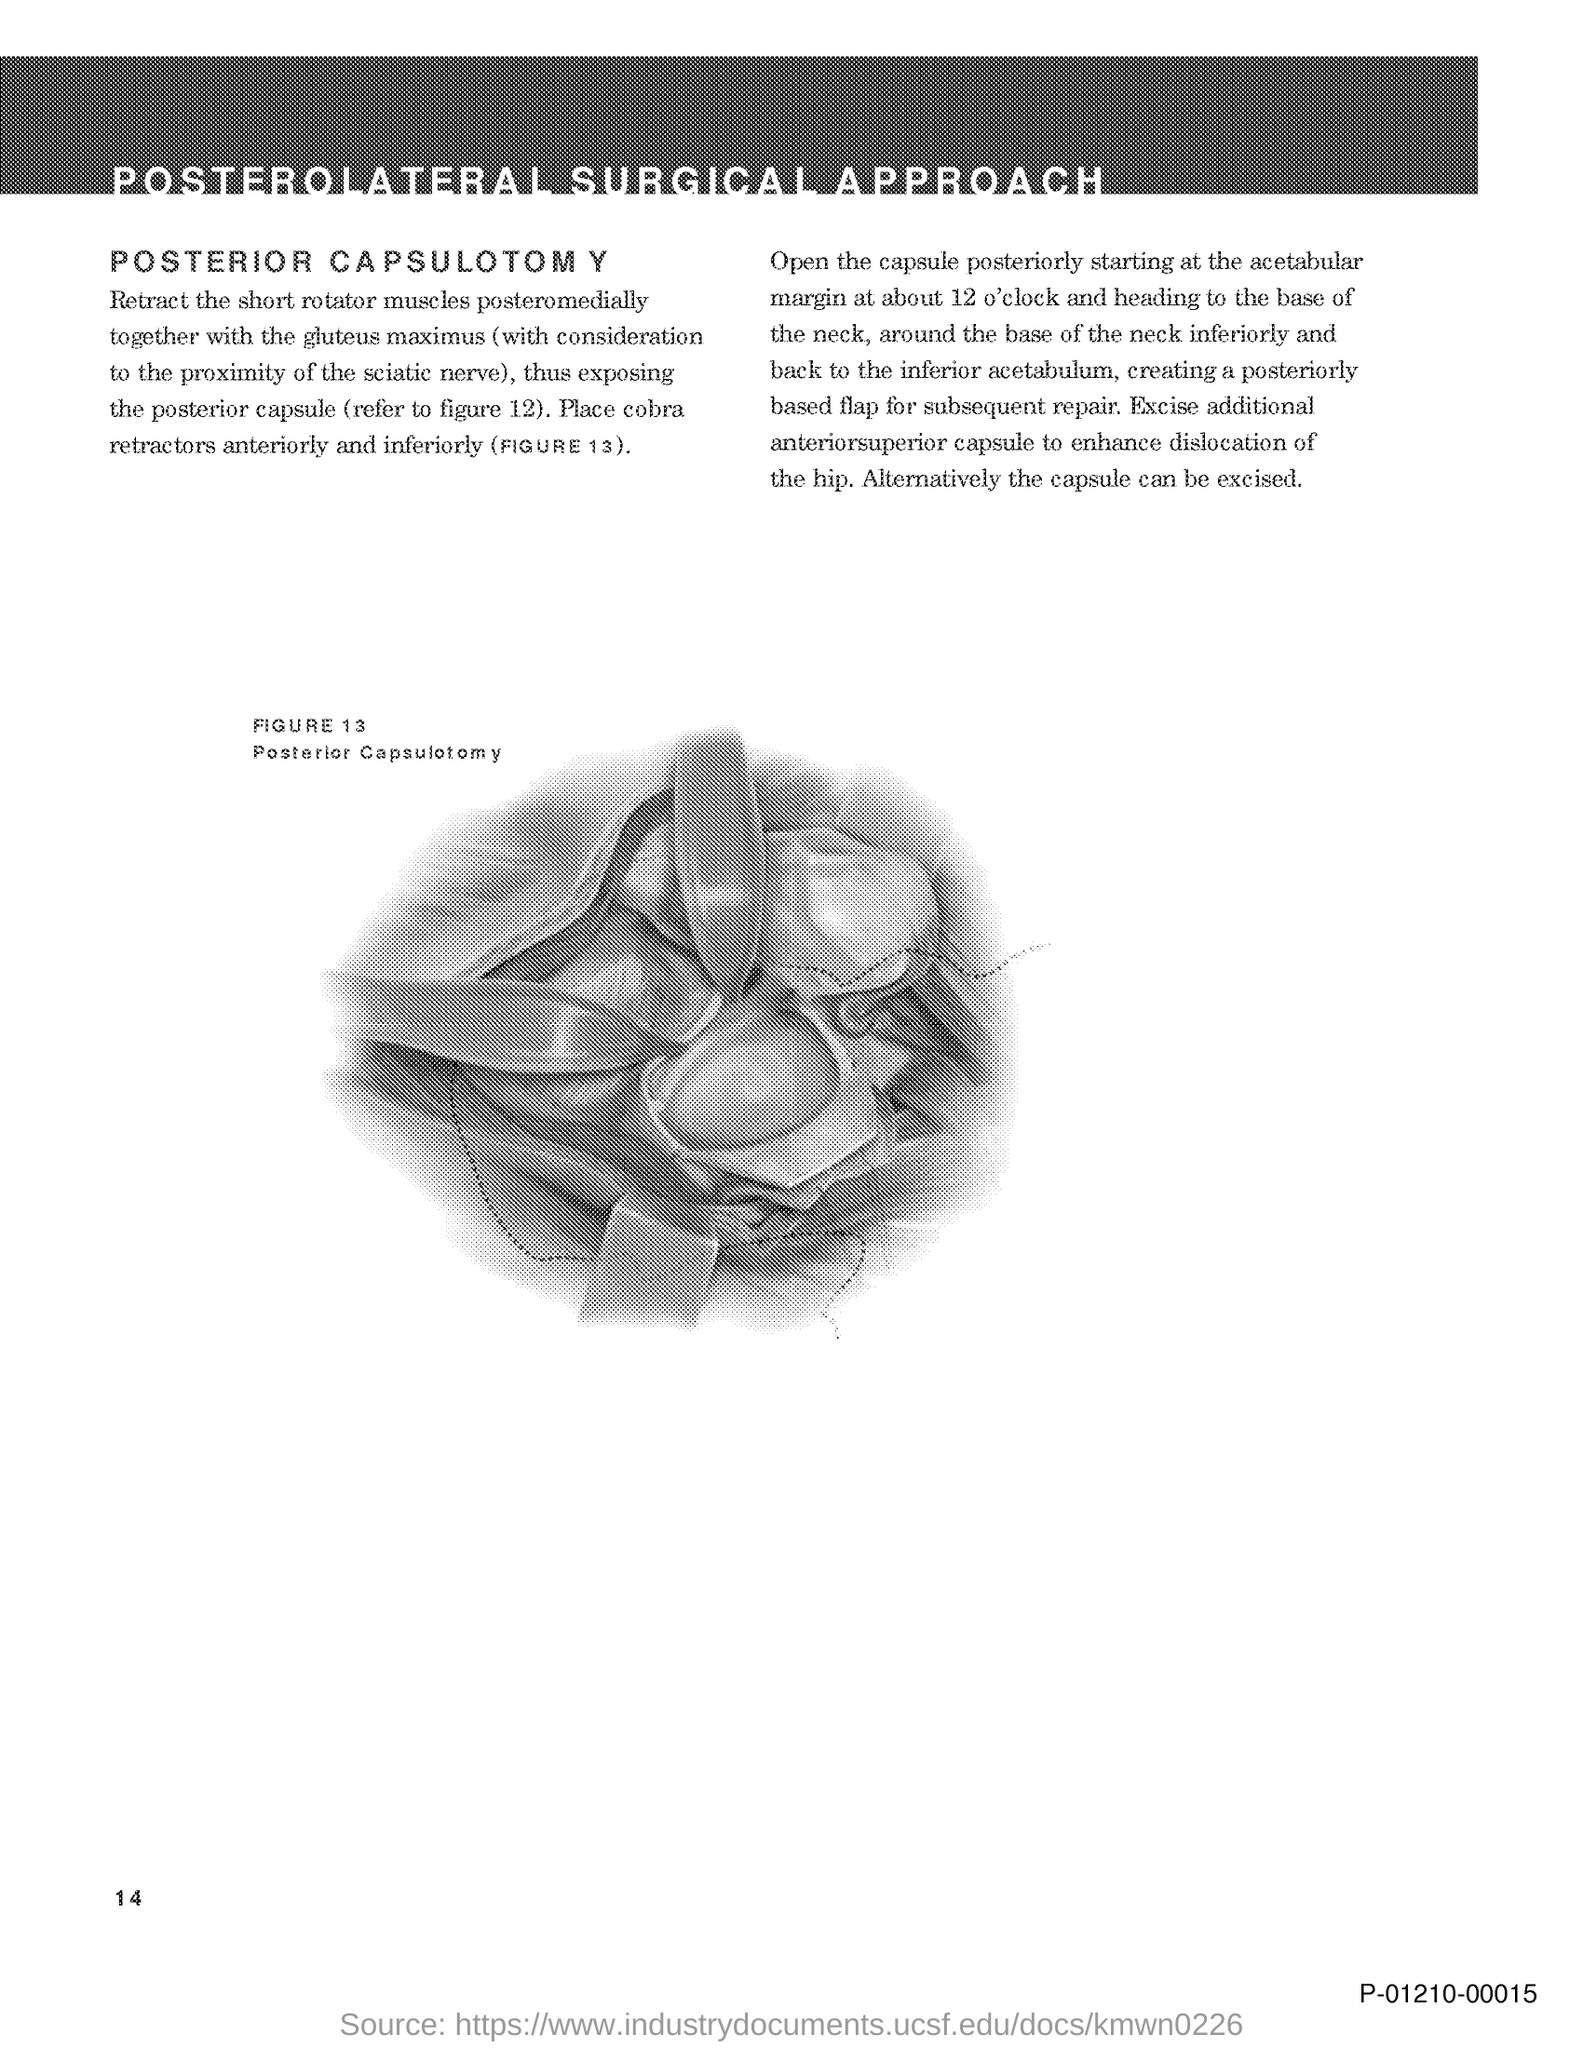Point out several critical features in this image. The title of the document is 'Posterolateral Surgical Approach.' 